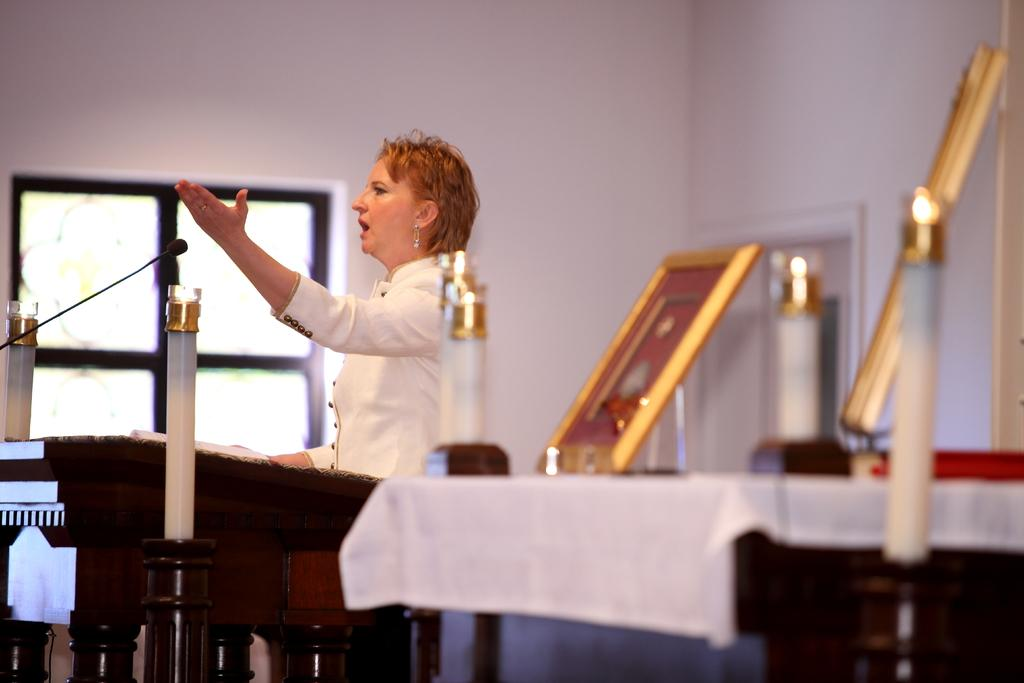Who is present in the image? There is a woman in the image. What object is visible in the image that is typically used for amplifying sound? There is a microphone (mike) in the image. What is covering the table in the image? There is a tablecloth in the image. What is framing the objects in the image? There is a frame in the image. Can you describe any other objects present in the image? There are other objects in the image, but their specific details are not mentioned in the provided facts. What can be seen in the background of the image? There is a wall and a window in the background of the image. What type of milk is being served in the image? There is no milk present in the image. What type of stitch is being used to sew the woman's dress in the image? There is no indication of the woman's dress or any stitching in the image. 